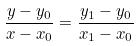Convert formula to latex. <formula><loc_0><loc_0><loc_500><loc_500>\frac { y - y _ { 0 } } { x - x _ { 0 } } = \frac { y _ { 1 } - y _ { 0 } } { x _ { 1 } - x _ { 0 } }</formula> 